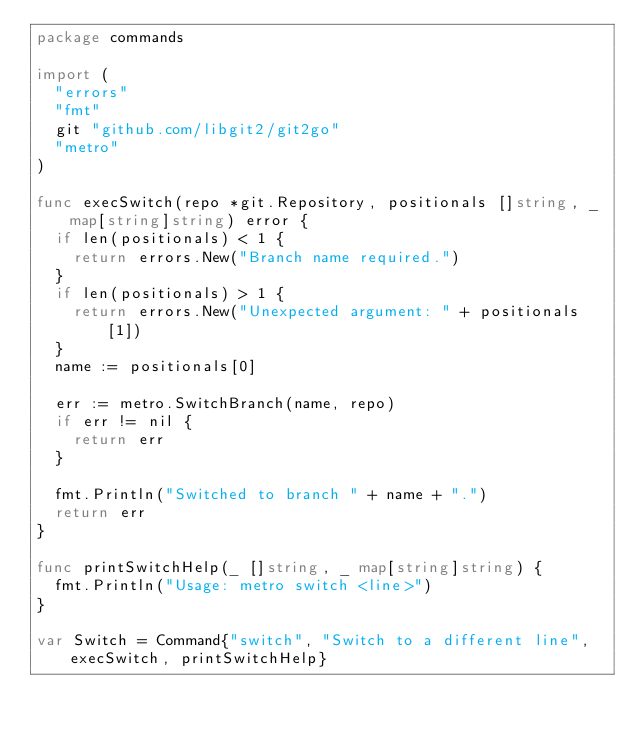<code> <loc_0><loc_0><loc_500><loc_500><_Go_>package commands

import (
	"errors"
	"fmt"
	git "github.com/libgit2/git2go"
	"metro"
)

func execSwitch(repo *git.Repository, positionals []string, _ map[string]string) error {
	if len(positionals) < 1 {
		return errors.New("Branch name required.")
	}
	if len(positionals) > 1 {
		return errors.New("Unexpected argument: " + positionals[1])
	}
	name := positionals[0]

	err := metro.SwitchBranch(name, repo)
	if err != nil {
		return err
	}

	fmt.Println("Switched to branch " + name + ".")
	return err
}

func printSwitchHelp(_ []string, _ map[string]string) {
	fmt.Println("Usage: metro switch <line>")
}

var Switch = Command{"switch", "Switch to a different line", execSwitch, printSwitchHelp}
</code> 